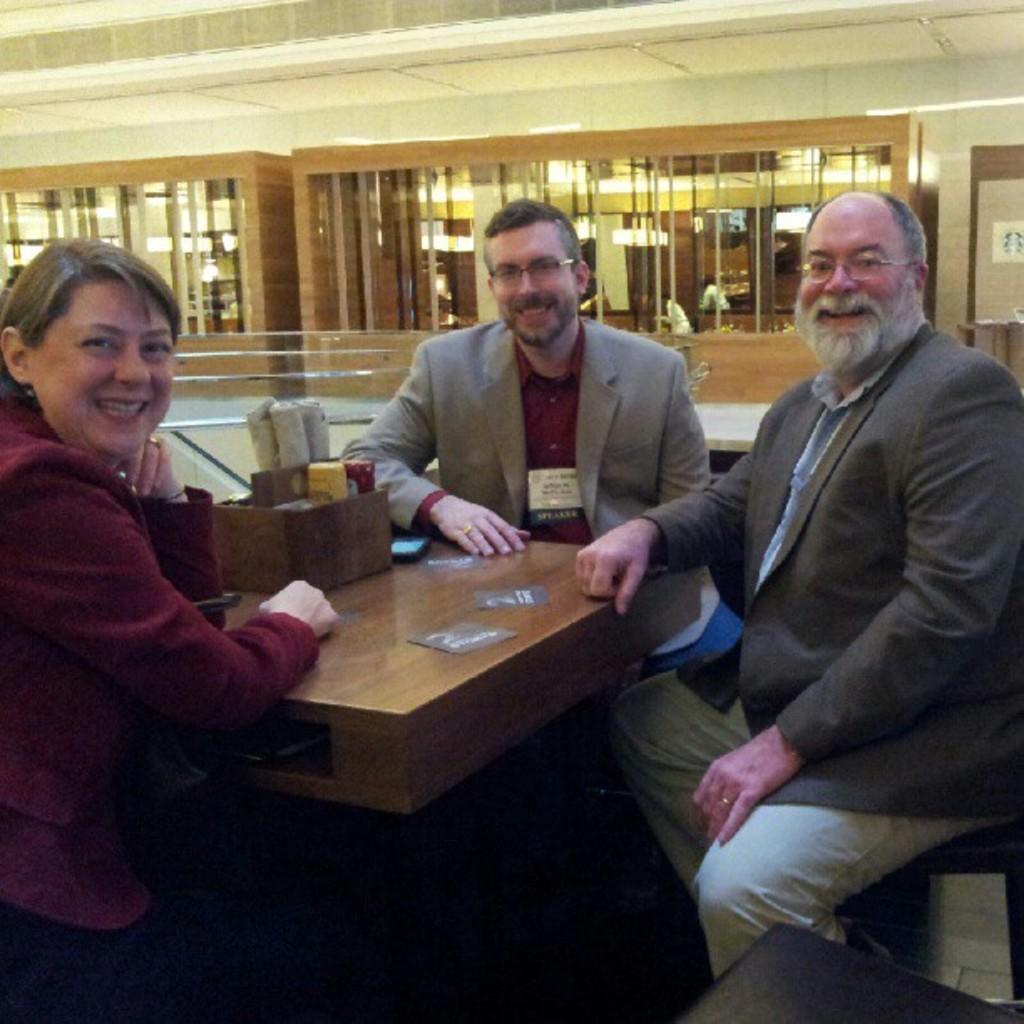How many people are in the image? There are three people in the image: two men and a woman. What are the people doing in the image? The people are sitting in the image. What can be observed about the people's expressions in the image? The people have smiles on their faces in the image. What type of design can be seen on the legs of the table in the image? There is no table present in the image, so it is not possible to determine the design on its legs. 